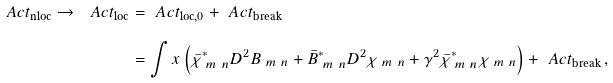Convert formula to latex. <formula><loc_0><loc_0><loc_500><loc_500>\ A c t _ { \text {nloc} } \to \ A c t _ { \text {loc} } & = \ A c t _ { \text {loc,0} } + \ A c t _ { \text {break} } \\ & = \int x \left ( \bar { \chi } _ { \ m \ n } ^ { * } D ^ { 2 } B _ { \ m \ n } + \bar { B } _ { \ m \ n } ^ { * } D ^ { 2 } \chi _ { \ m \ n } + \gamma ^ { 2 } \bar { \chi } _ { \ m \ n } ^ { * } \chi _ { \ m \ n } \right ) + \ A c t _ { \text {break} } \, ,</formula> 